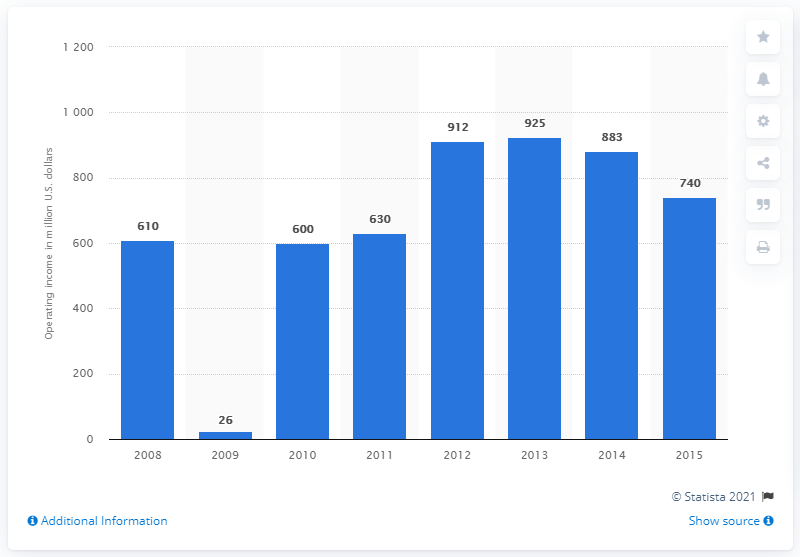Mention a couple of crucial points in this snapshot. Starwood's operating income in 2015 was approximately $740 million in dollars. 